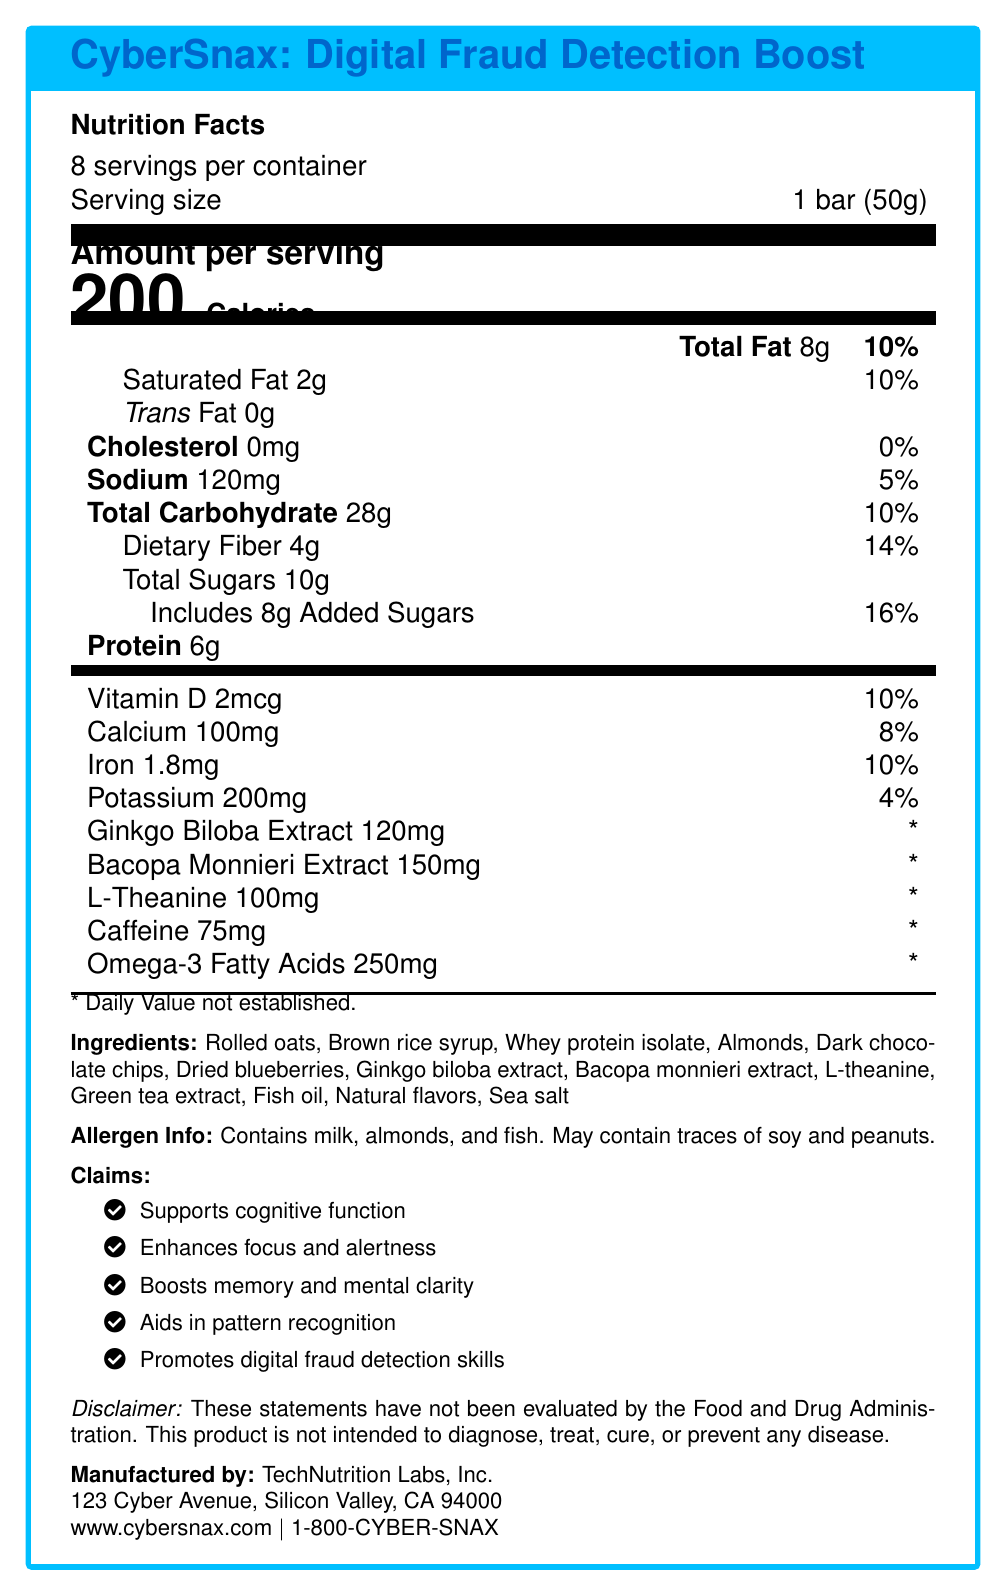what is the serving size? The serving size is stated directly as "1 bar (50g)" under the "Nutrition Facts" section.
Answer: 1 bar (50g) how many calories are in one serving? The document lists "200 Calories" under the "Nutrition Facts" section for the amount per serving.
Answer: 200 how much saturated fat does one serving contain? The "Nutrition Facts" section shows "Saturated Fat 2g."
Answer: 2g what is the total amount of carbohydrates per serving? The document lists "Total Carbohydrate 28g" in the "Nutrition Facts" section.
Answer: 28g what vitamins and minerals are present in the bar? The listed vitamins and minerals in the "Nutrition Facts" section are Vitamin D, Calcium, Iron, and Potassium.
Answer: Vitamin D, Calcium, Iron, Potassium how much caffeine is in each serving? The document lists "Caffeine 75mg" under the nutritional information.
Answer: 75mg what are the claims made about the product? These claims are listed under the "Claims" section of the document.
Answer: Supports cognitive function, Enhances focus and alertness, Boosts memory and mental clarity, Aids in pattern recognition, Promotes digital fraud detection skills what allergens are listed for the product? The document mentions "Contains milk, almonds, and fish. May contain traces of soy and peanuts." under "Allergen Info."
Answer: Milk, almonds, fish, soy, peanuts in terms of fats, what information is provided? The information provided includes "Total Fat 8g," "Saturated Fat 2g," and "Trans Fat 0g" in the "Nutrition Facts" section.
Answer: Total Fat 8g, Saturated Fat 2g, Trans Fat 0g how many servings are there per container? The document states "8 servings per container" under the "Nutrition Facts" section.
Answer: 8 which of the following ingredients is found in the product? A. Cocoa butter B. Whey protein isolate C. Cane sugar D. Sunflower oil The ingredient list in the document includes "Whey protein isolate."
Answer: B. Whey protein isolate how much of the daily value of dietary fiber does each bar provide? A. 8% B. 10% C. 14% D. 20% The document lists "Dietary Fiber 4g 14%" in the "Nutrition Facts" section.
Answer: C. 14% does the product contain any trans fat? The document states "Trans Fat 0g" in the "Nutrition Facts" section.
Answer: No summarize the document briefly. The document gives comprehensive nutritional and ingredient details for the product, emphasizing its benefits for cognitive function and fraud detection, along with manufacturing and contact information.
Answer: The document provides the nutrition facts for "CyberSnax: Digital Fraud Detection Boost," detailing the contents per serving, including calories, fats, carbohydrates, protein, vitamins, and minerals. It highlights key ingredients, allergen information, and claims related to cognitive and digital fraud detection benefits, along with manufacturer details. what is the exact address of the manufacturer? The document provides the manufacturer's address as "123 Cyber Avenue, Silicon Valley, CA 94000" but does not specify additional details such as suite number, if applicable.
Answer: Cannot be determined 